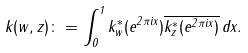<formula> <loc_0><loc_0><loc_500><loc_500>k ( w , z ) \colon = \int _ { 0 } ^ { 1 } k _ { w } ^ { \ast } ( e ^ { 2 \pi i x } ) \overline { k _ { z } ^ { \ast } ( e ^ { 2 \pi i x } ) } \, d x .</formula> 